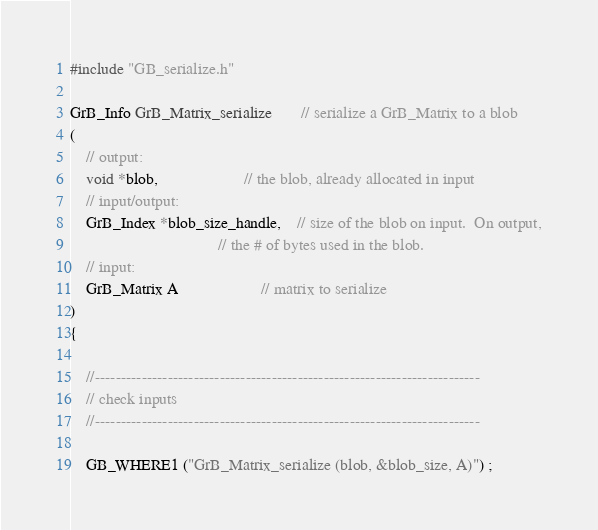Convert code to text. <code><loc_0><loc_0><loc_500><loc_500><_C_>#include "GB_serialize.h"

GrB_Info GrB_Matrix_serialize       // serialize a GrB_Matrix to a blob
(
    // output:
    void *blob,                     // the blob, already allocated in input
    // input/output:
    GrB_Index *blob_size_handle,    // size of the blob on input.  On output,
                                    // the # of bytes used in the blob.
    // input:
    GrB_Matrix A                    // matrix to serialize
)
{ 

    //--------------------------------------------------------------------------
    // check inputs
    //--------------------------------------------------------------------------

    GB_WHERE1 ("GrB_Matrix_serialize (blob, &blob_size, A)") ;</code> 